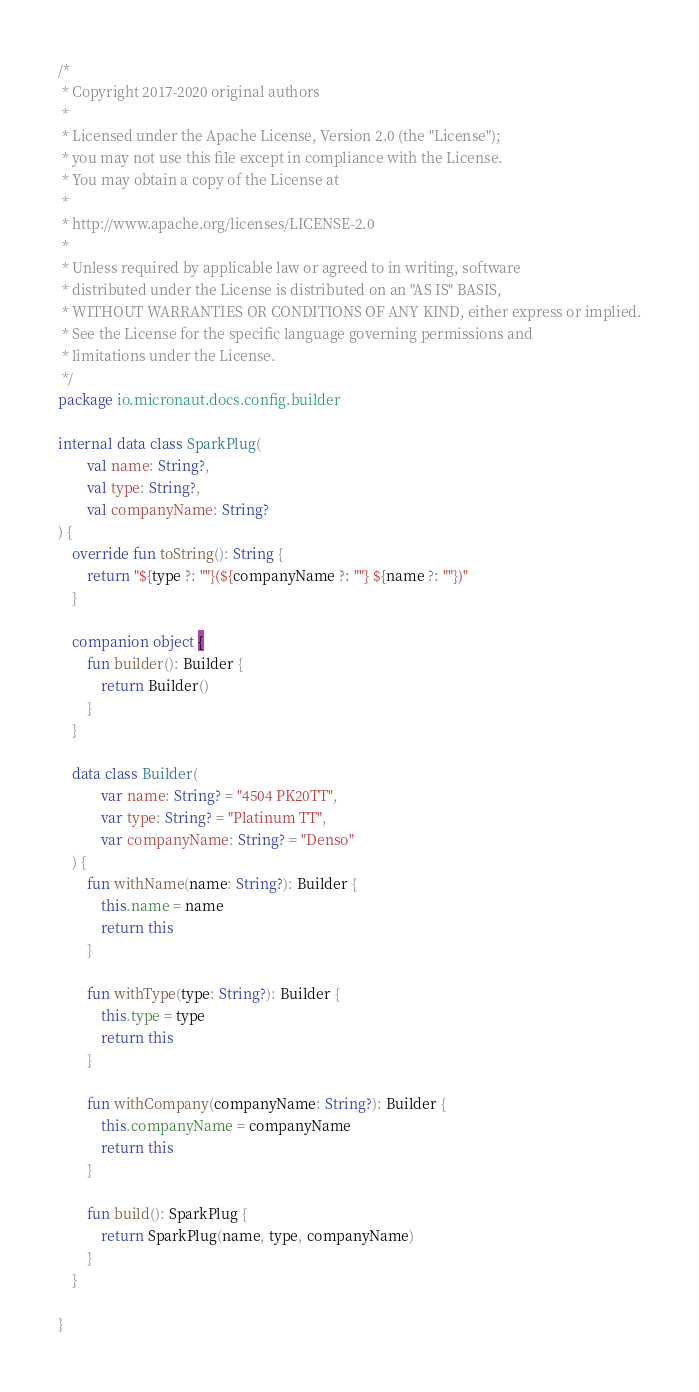<code> <loc_0><loc_0><loc_500><loc_500><_Kotlin_>/*
 * Copyright 2017-2020 original authors
 *
 * Licensed under the Apache License, Version 2.0 (the "License");
 * you may not use this file except in compliance with the License.
 * You may obtain a copy of the License at
 *
 * http://www.apache.org/licenses/LICENSE-2.0
 *
 * Unless required by applicable law or agreed to in writing, software
 * distributed under the License is distributed on an "AS IS" BASIS,
 * WITHOUT WARRANTIES OR CONDITIONS OF ANY KIND, either express or implied.
 * See the License for the specific language governing permissions and
 * limitations under the License.
 */
package io.micronaut.docs.config.builder

internal data class SparkPlug(
        val name: String?,
        val type: String?,
        val companyName: String?
) {
    override fun toString(): String {
        return "${type ?: ""}(${companyName ?: ""} ${name ?: ""})"
    }

    companion object {
        fun builder(): Builder {
            return Builder()
        }
    }

    data class Builder(
            var name: String? = "4504 PK20TT",
            var type: String? = "Platinum TT",
            var companyName: String? = "Denso"
    ) {
        fun withName(name: String?): Builder {
            this.name = name
            return this
        }

        fun withType(type: String?): Builder {
            this.type = type
            return this
        }

        fun withCompany(companyName: String?): Builder {
            this.companyName = companyName
            return this
        }

        fun build(): SparkPlug {
            return SparkPlug(name, type, companyName)
        }
    }

}</code> 